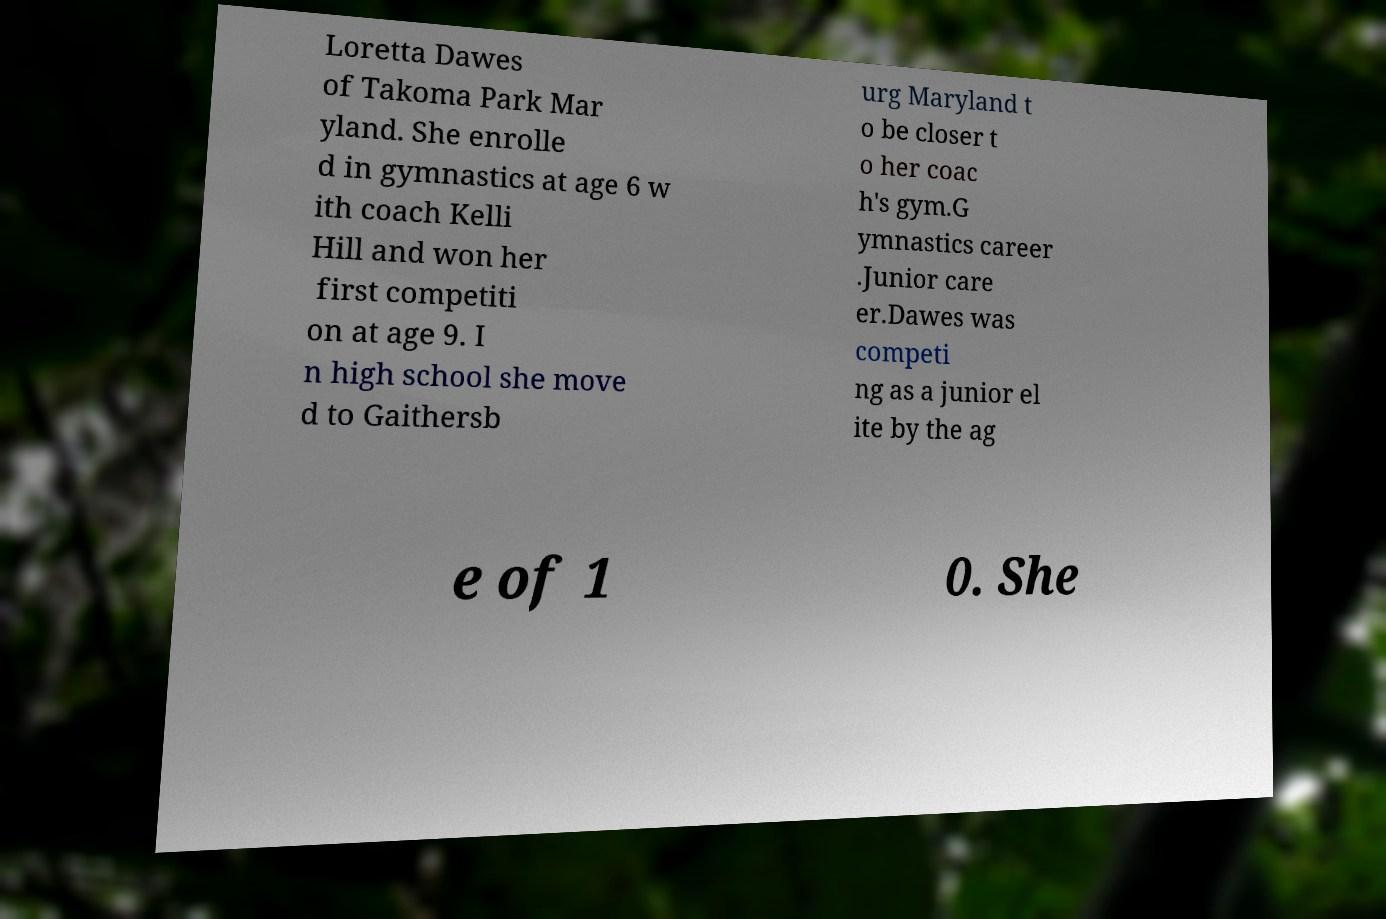Could you extract and type out the text from this image? Loretta Dawes of Takoma Park Mar yland. She enrolle d in gymnastics at age 6 w ith coach Kelli Hill and won her first competiti on at age 9. I n high school she move d to Gaithersb urg Maryland t o be closer t o her coac h's gym.G ymnastics career .Junior care er.Dawes was competi ng as a junior el ite by the ag e of 1 0. She 